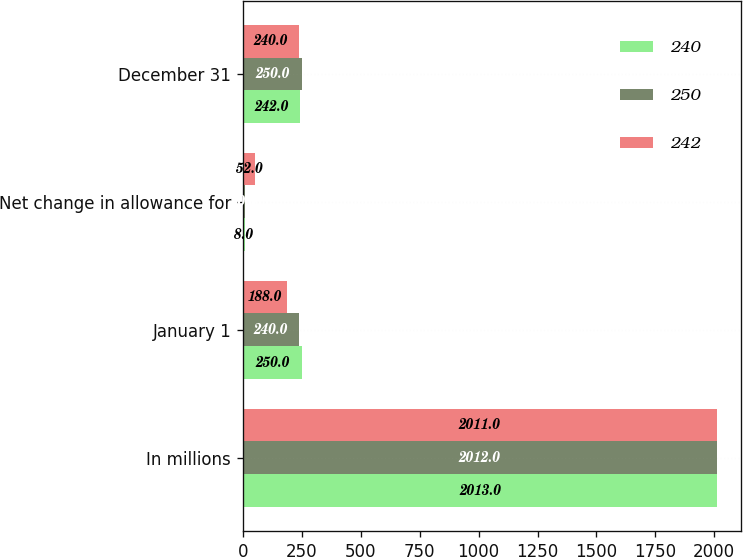<chart> <loc_0><loc_0><loc_500><loc_500><stacked_bar_chart><ecel><fcel>In millions<fcel>January 1<fcel>Net change in allowance for<fcel>December 31<nl><fcel>240<fcel>2013<fcel>250<fcel>8<fcel>242<nl><fcel>250<fcel>2012<fcel>240<fcel>10<fcel>250<nl><fcel>242<fcel>2011<fcel>188<fcel>52<fcel>240<nl></chart> 